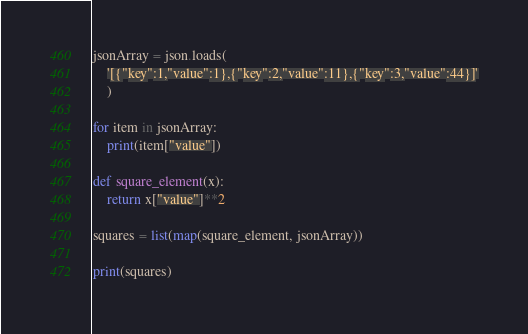<code> <loc_0><loc_0><loc_500><loc_500><_Python_>
jsonArray = json.loads(
    '[{"key":1,"value":1},{"key":2,"value":11},{"key":3,"value":44}]'
    )

for item in jsonArray:
    print(item["value"])

def square_element(x):
    return x["value"]**2

squares = list(map(square_element, jsonArray))

print(squares)</code> 